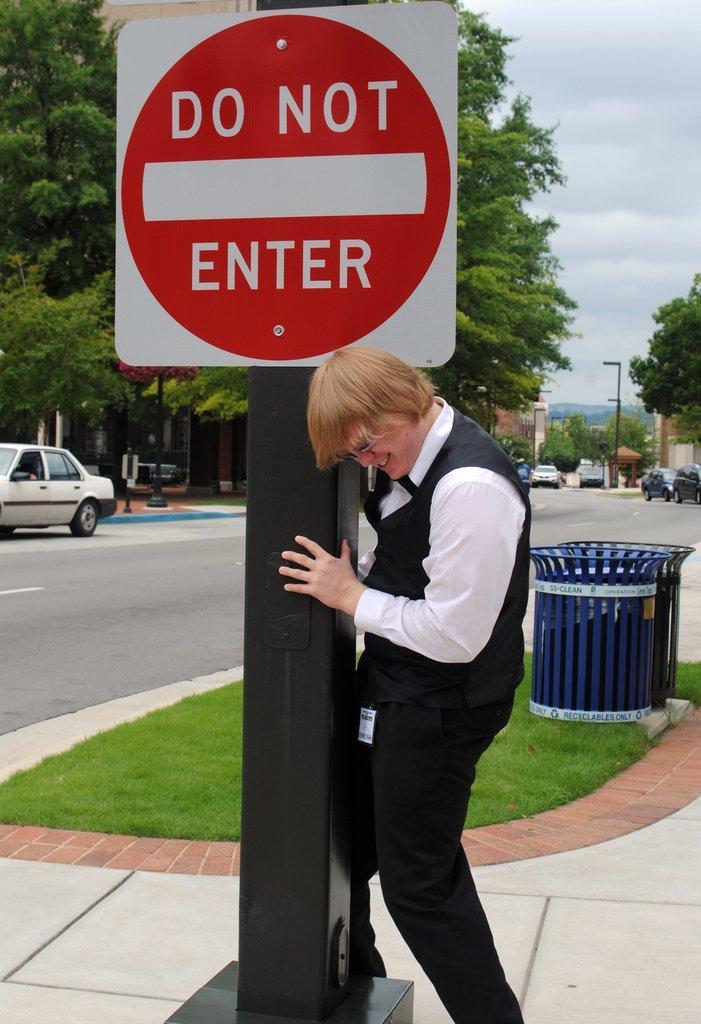Please provide a concise description of this image. In this image, at the middle there is a black color pole, on that pole there is a red color DO NOT ENTER sign board, there is a man standing and he is holding the pole, in the background there are some cars and there are some green color trees, at the top there is a sky. 